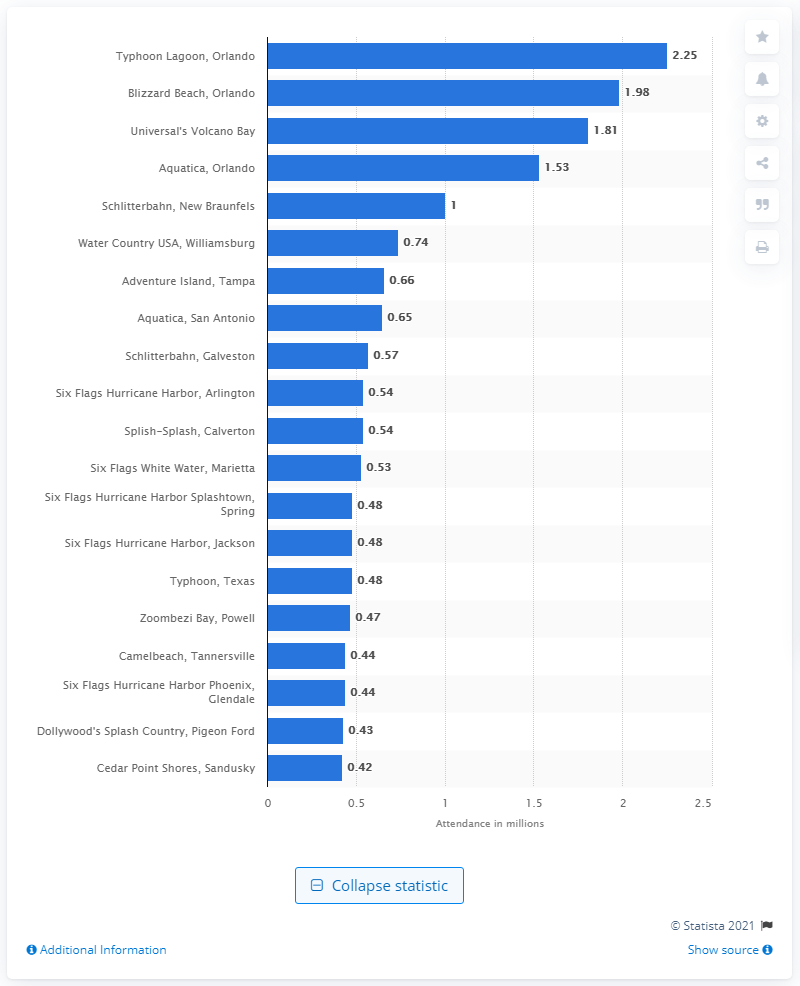Identify some key points in this picture. In 2019, approximately 2.25 people visited Typhoon Lagoon. 